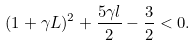Convert formula to latex. <formula><loc_0><loc_0><loc_500><loc_500>( 1 + \gamma L ) ^ { 2 } + \frac { 5 \gamma l } 2 - \frac { 3 } { 2 } < 0 .</formula> 